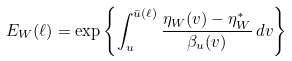<formula> <loc_0><loc_0><loc_500><loc_500>E _ { W } ( \ell ) = \exp \left \{ \int _ { u } ^ { \bar { u } ( \ell ) } \frac { \eta _ { W } ( v ) - \eta _ { W } ^ { * } } { \beta _ { u } ( v ) } \, d v \right \}</formula> 